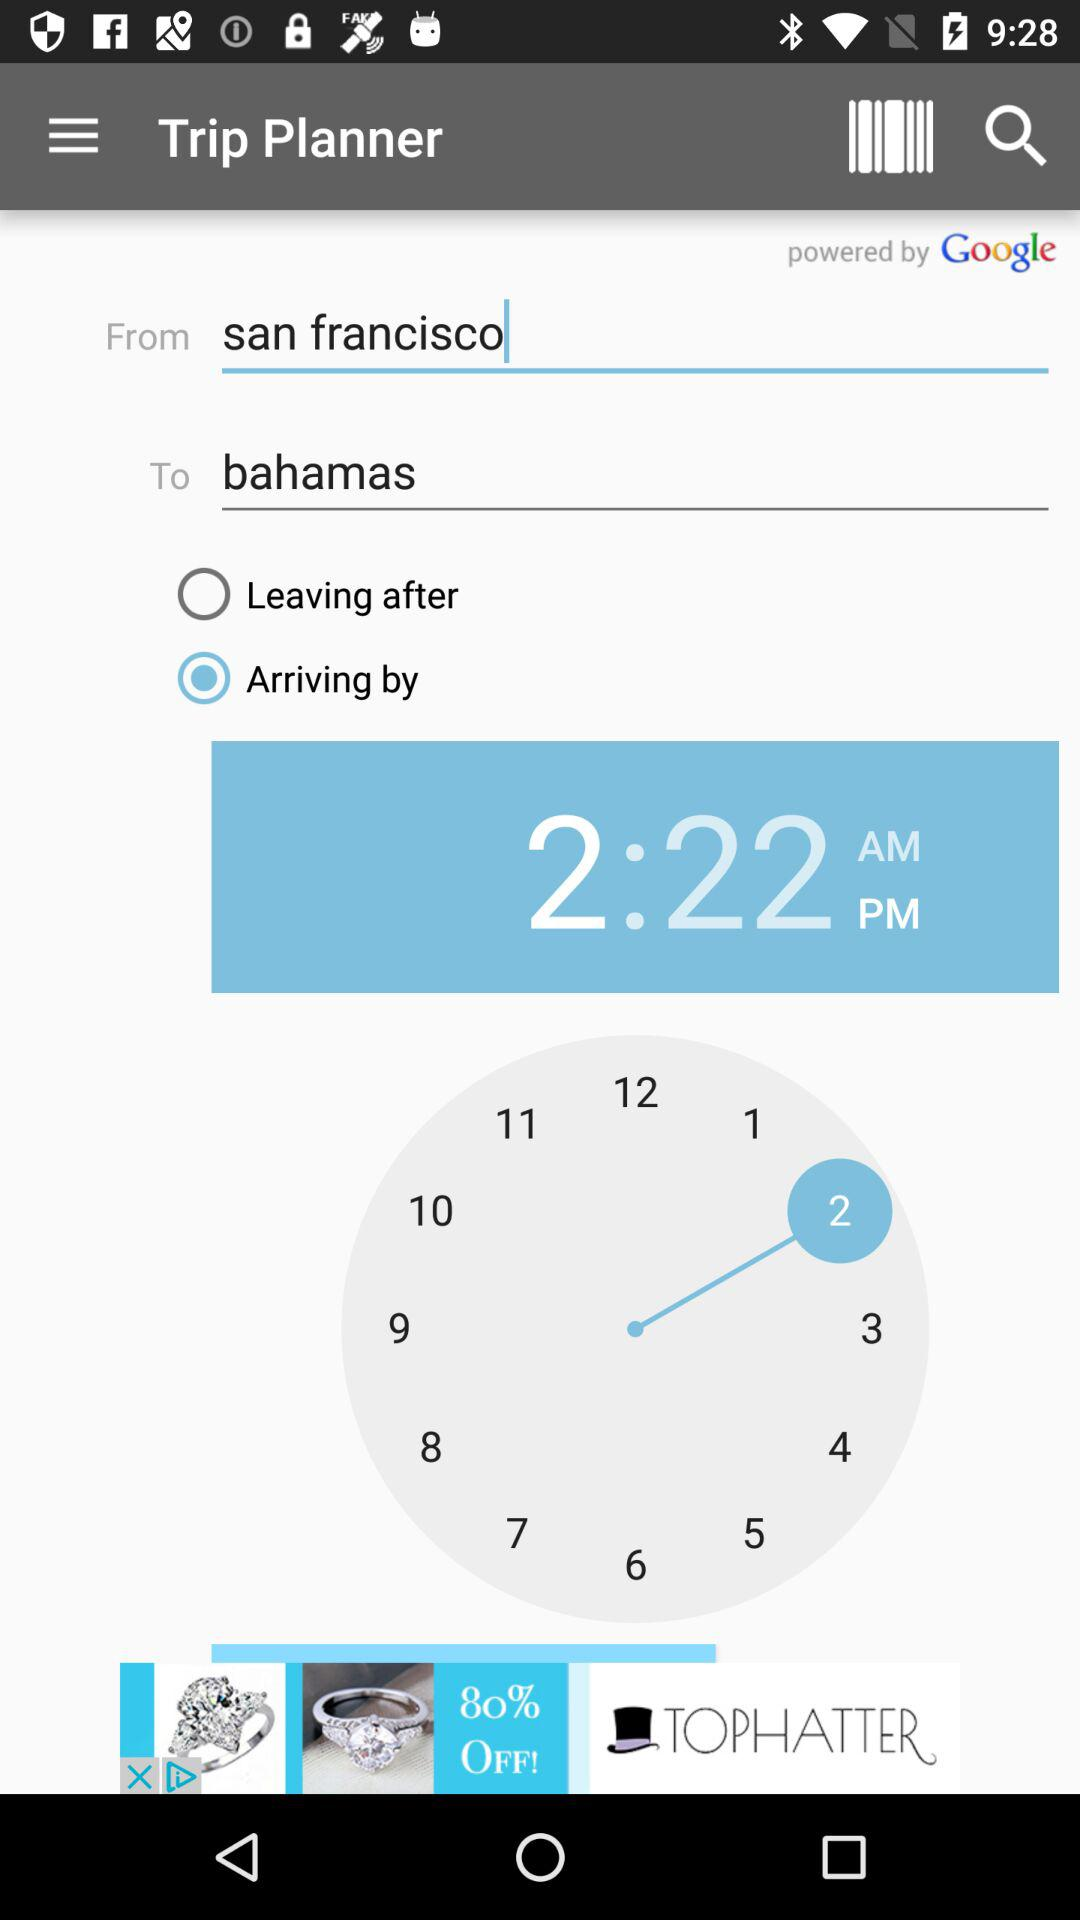What is the displayed time? The displayed time is 2:22 PM. 